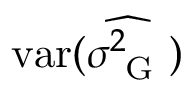Convert formula to latex. <formula><loc_0><loc_0><loc_500><loc_500>v a r ( \widehat { \sigma _ { G } ^ { 2 } } )</formula> 